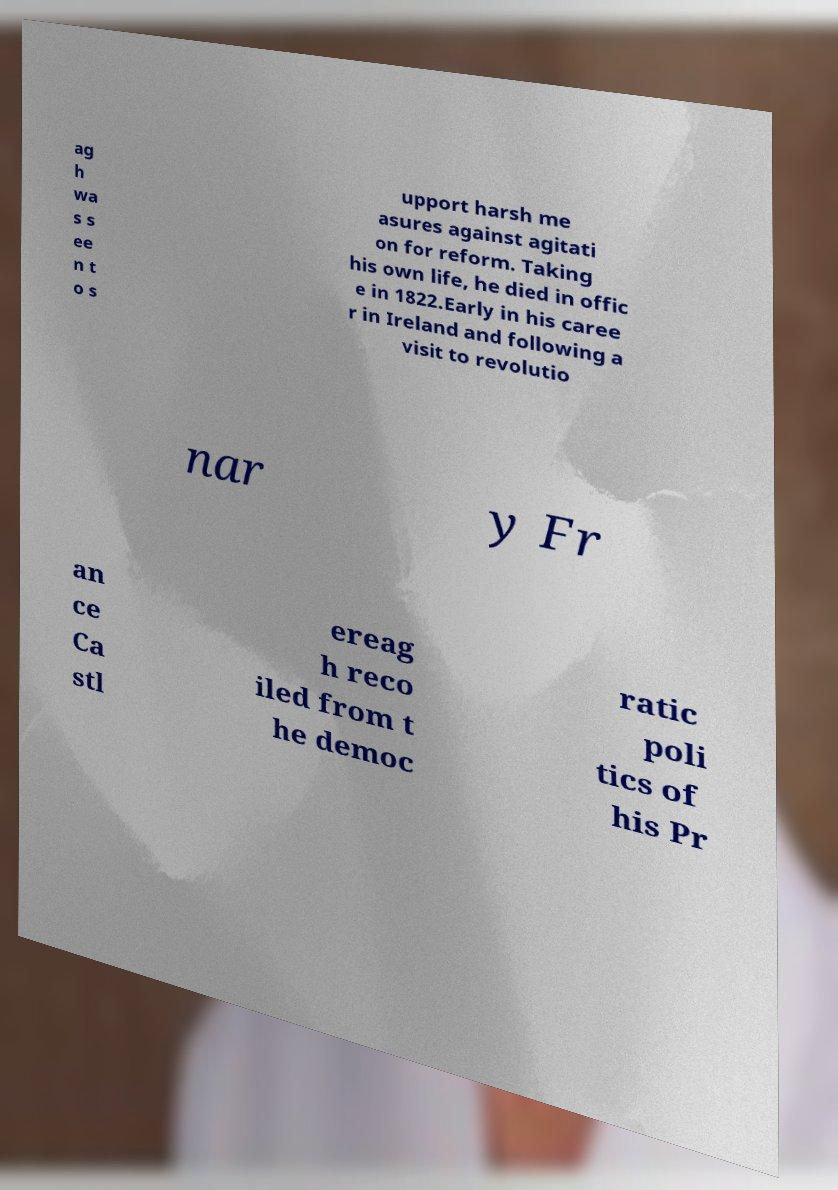Can you read and provide the text displayed in the image?This photo seems to have some interesting text. Can you extract and type it out for me? ag h wa s s ee n t o s upport harsh me asures against agitati on for reform. Taking his own life, he died in offic e in 1822.Early in his caree r in Ireland and following a visit to revolutio nar y Fr an ce Ca stl ereag h reco iled from t he democ ratic poli tics of his Pr 